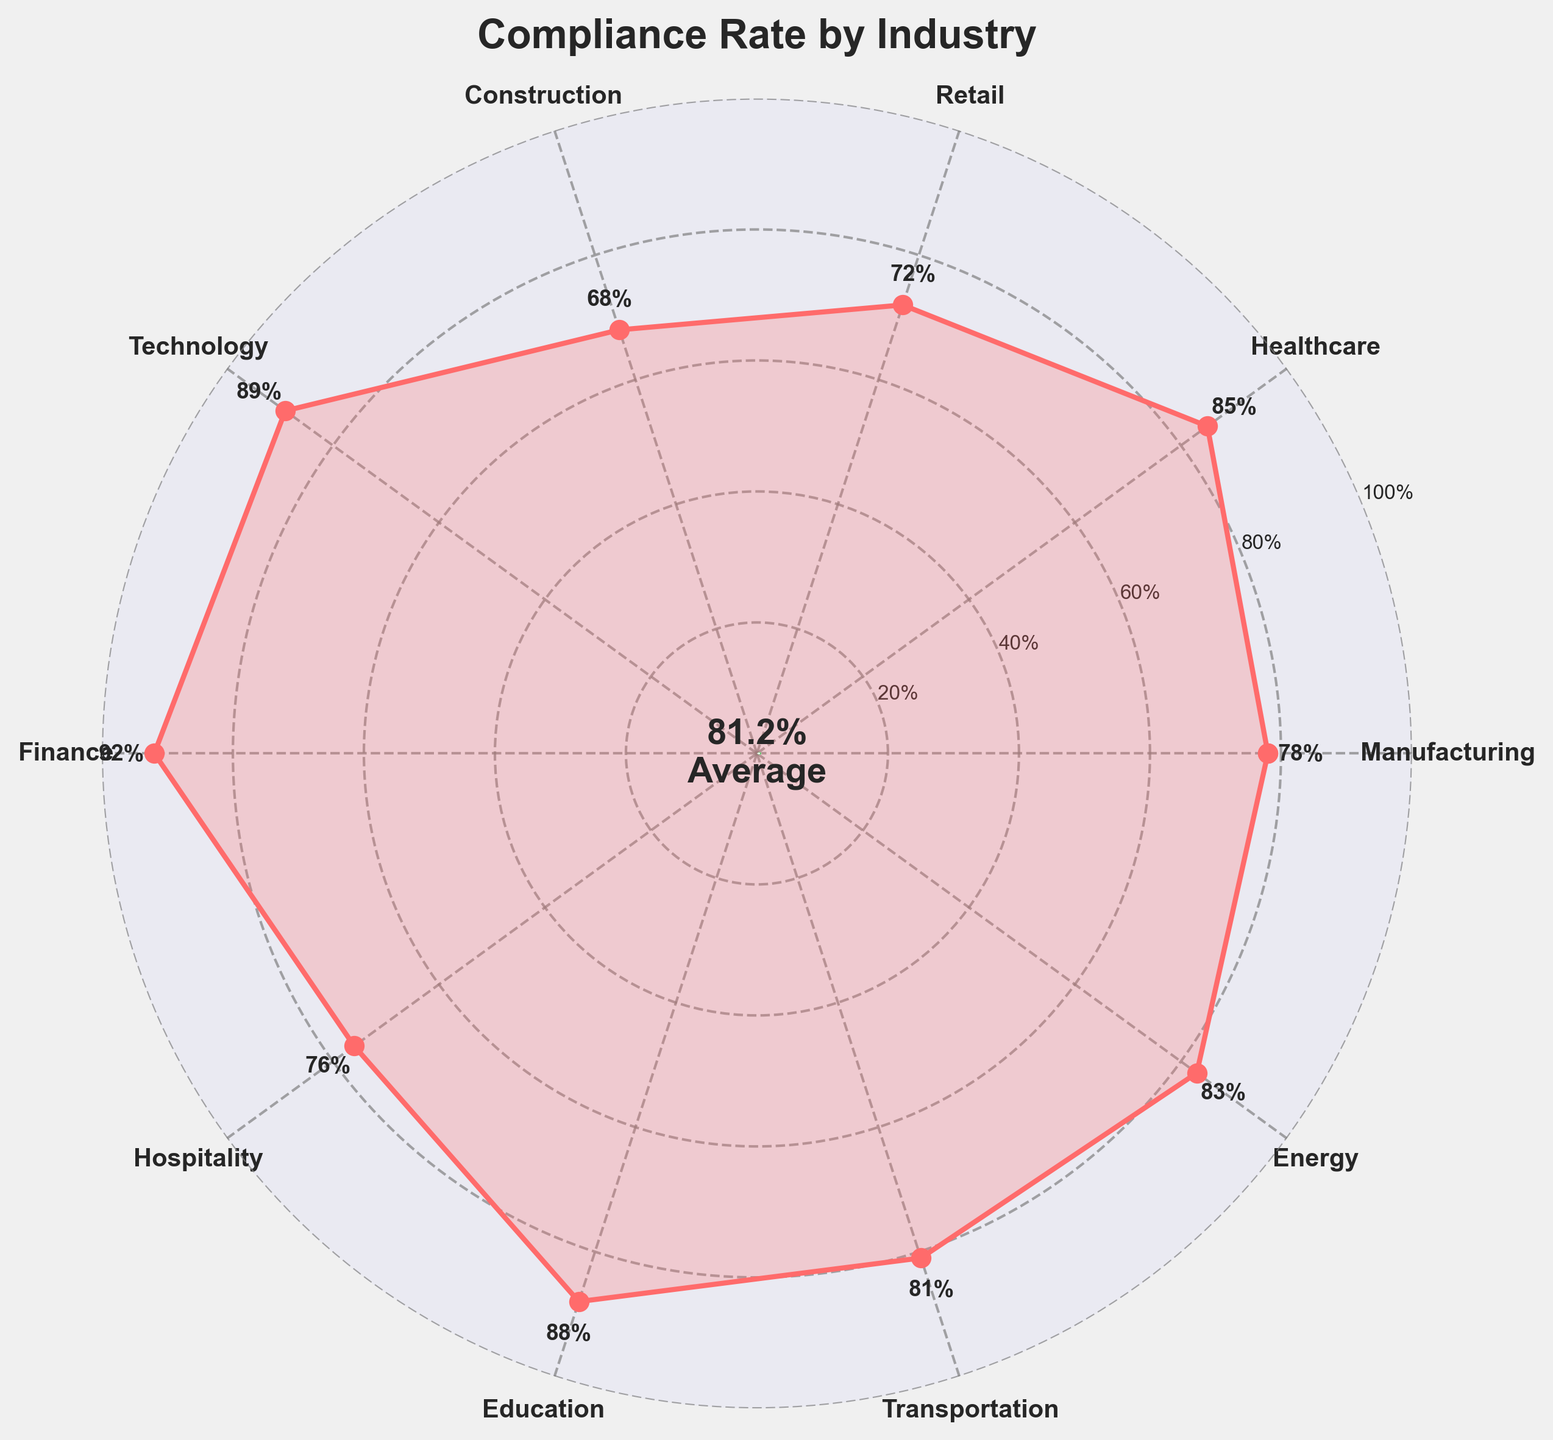What's the compliance rate of the Retail industry? The compliance rate of the Retail industry can be seen directly on the figure by looking at the rate indicated for Retail.
Answer: 72% Which industry has the highest compliance rate? The highest compliance rate can be determined by identifying the industry with the largest percentage value in the figure.
Answer: Finance What is the average compliance rate across all industries? The average compliance rate is displayed in the center of the gauge chart, which represents the mean compliance rate across all listed industries.
Answer: 81% How does the compliance rate of Technology compare to that of Education? By comparing the compliance rates shown for Technology and Education in the figure, we can see which is higher or lower.
Answer: Technology is lower than Education What is the compliance rate for the industry with the second lowest compliance? The second lowest compliance rate is identified by inspecting the compliance rates for each industry and finding the second smallest value.
Answer: Construction Which industries have compliance rates greater than 80%? By inspecting the compliance rates for each industry listed in the figure, we can identify those that are greater than 80%.
Answer: Healthcare, Technology, Finance, Education, Transportation, Energy What is the difference between the highest and the lowest compliance rates? The difference is calculated by subtracting the lowest compliance rate from the highest compliance rate. The highest is 92% (Finance) and the lowest is 68% (Construction). So, 92 - 68 = 24.
Answer: 24% How many industries have a compliance rate below the average rate? The answer can be found by counting the industries with compliance rates less than the average compliance rate shown in the center. The figure lists rates and the average is 81%, so count the industries below this percentage.
Answer: 5 What does the gauge in the center represent? The gauge in the center of the chart indicates the average compliance rate across all industry sectors.
Answer: Average compliance rate 